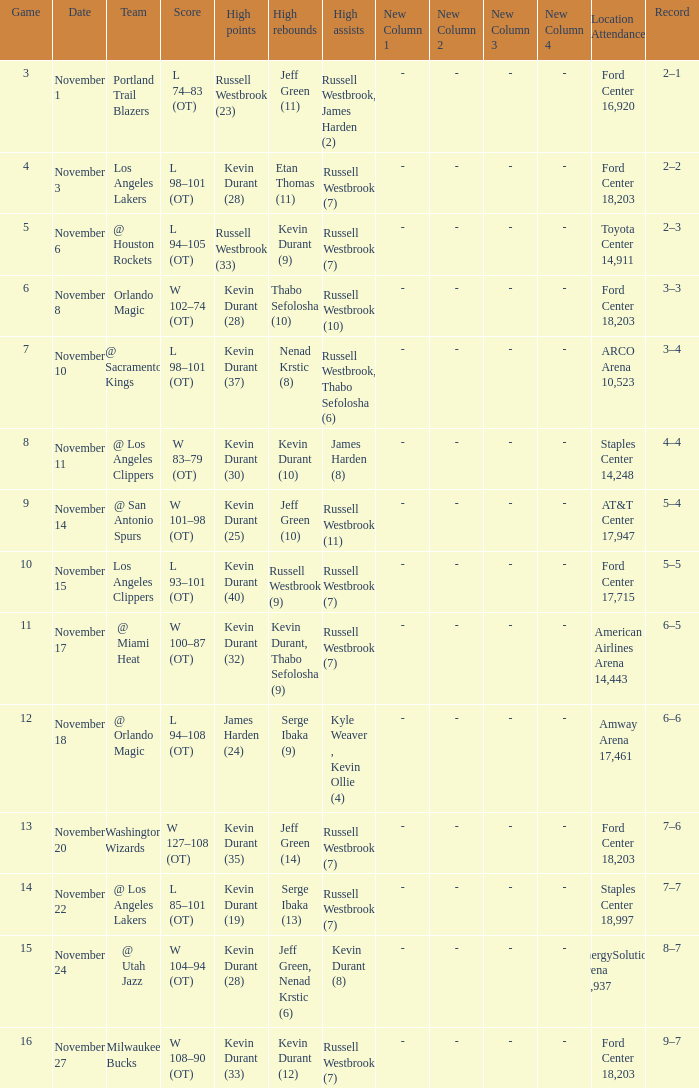When was the game number 3 played? November 1. 